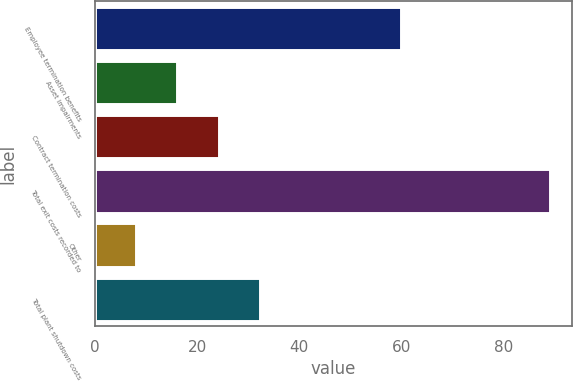Convert chart. <chart><loc_0><loc_0><loc_500><loc_500><bar_chart><fcel>Employee termination benefits<fcel>Asset impairments<fcel>Contract termination costs<fcel>Total exit costs recorded to<fcel>Other<fcel>Total plant shutdown costs<nl><fcel>60<fcel>16.1<fcel>24.2<fcel>89<fcel>8<fcel>32.3<nl></chart> 